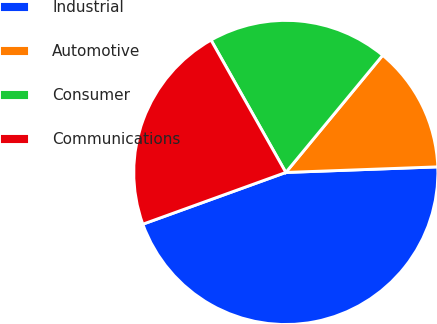<chart> <loc_0><loc_0><loc_500><loc_500><pie_chart><fcel>Industrial<fcel>Automotive<fcel>Consumer<fcel>Communications<nl><fcel>45.06%<fcel>13.42%<fcel>19.18%<fcel>22.34%<nl></chart> 